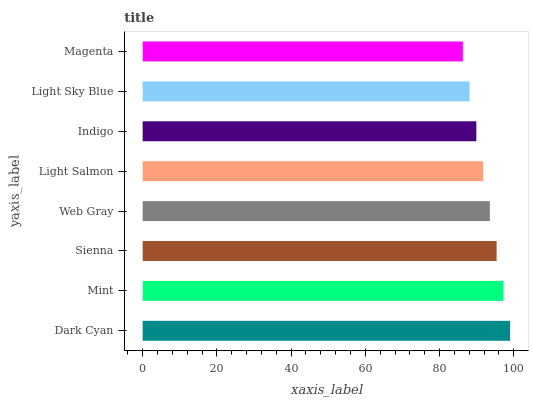Is Magenta the minimum?
Answer yes or no. Yes. Is Dark Cyan the maximum?
Answer yes or no. Yes. Is Mint the minimum?
Answer yes or no. No. Is Mint the maximum?
Answer yes or no. No. Is Dark Cyan greater than Mint?
Answer yes or no. Yes. Is Mint less than Dark Cyan?
Answer yes or no. Yes. Is Mint greater than Dark Cyan?
Answer yes or no. No. Is Dark Cyan less than Mint?
Answer yes or no. No. Is Web Gray the high median?
Answer yes or no. Yes. Is Light Salmon the low median?
Answer yes or no. Yes. Is Indigo the high median?
Answer yes or no. No. Is Indigo the low median?
Answer yes or no. No. 